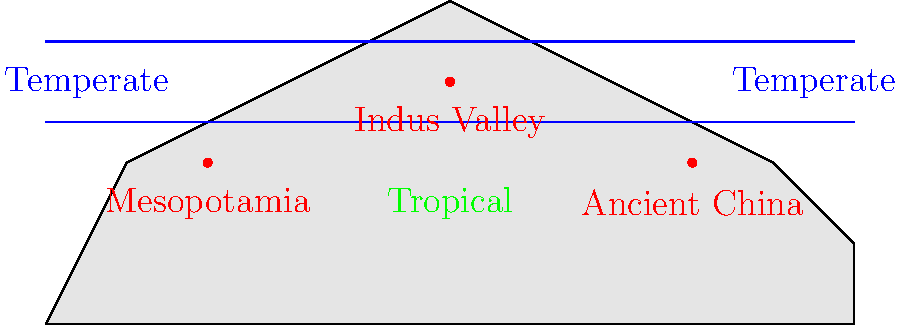Analyze the world map showing the locations of three ancient civilizations (Mesopotamia, Indus Valley, and Ancient China) in relation to historical climate zones. What pattern do you observe regarding the placement of these civilizations, and what hypothesis can you formulate about the relationship between climate and the development of early complex societies? To answer this question, let's analyze the map step-by-step:

1. Observe the climate zones:
   - The map shows three distinct climate zones: two temperate zones (north and south) and a tropical zone in the middle.

2. Locate the ancient civilizations:
   - Mesopotamia: Located in the western part of the map, near the boundary between temperate and tropical zones.
   - Indus Valley: Positioned in the center of the map, within the tropical zone.
   - Ancient China: Situated in the eastern part of the map, also near the boundary between temperate and tropical zones.

3. Identify the pattern:
   - All three civilizations are located either within or very close to the tropical zone.
   - They are positioned near major river systems (implied by their historical locations).

4. Formulate a hypothesis:
   - The pattern suggests that early complex societies tended to develop in regions with warm climates and access to water resources.
   - These areas likely provided favorable conditions for agriculture, which is crucial for supporting large populations and complex social structures.

5. Consider the implications:
   - The tropical and subtropical regions offer longer growing seasons and more consistent temperatures, which are beneficial for crop cultivation.
   - Proximity to rivers provides a reliable water source for irrigation, drinking, and transportation.

Based on this analysis, we can hypothesize that there is a strong correlation between the development of ancient civilizations and regions with warm climates and reliable water sources, as these factors create ideal conditions for agricultural surplus and population growth, which are essential for the emergence of complex societies.
Answer: Ancient civilizations clustered in warm, well-watered regions, suggesting climate and water access were crucial for their development. 